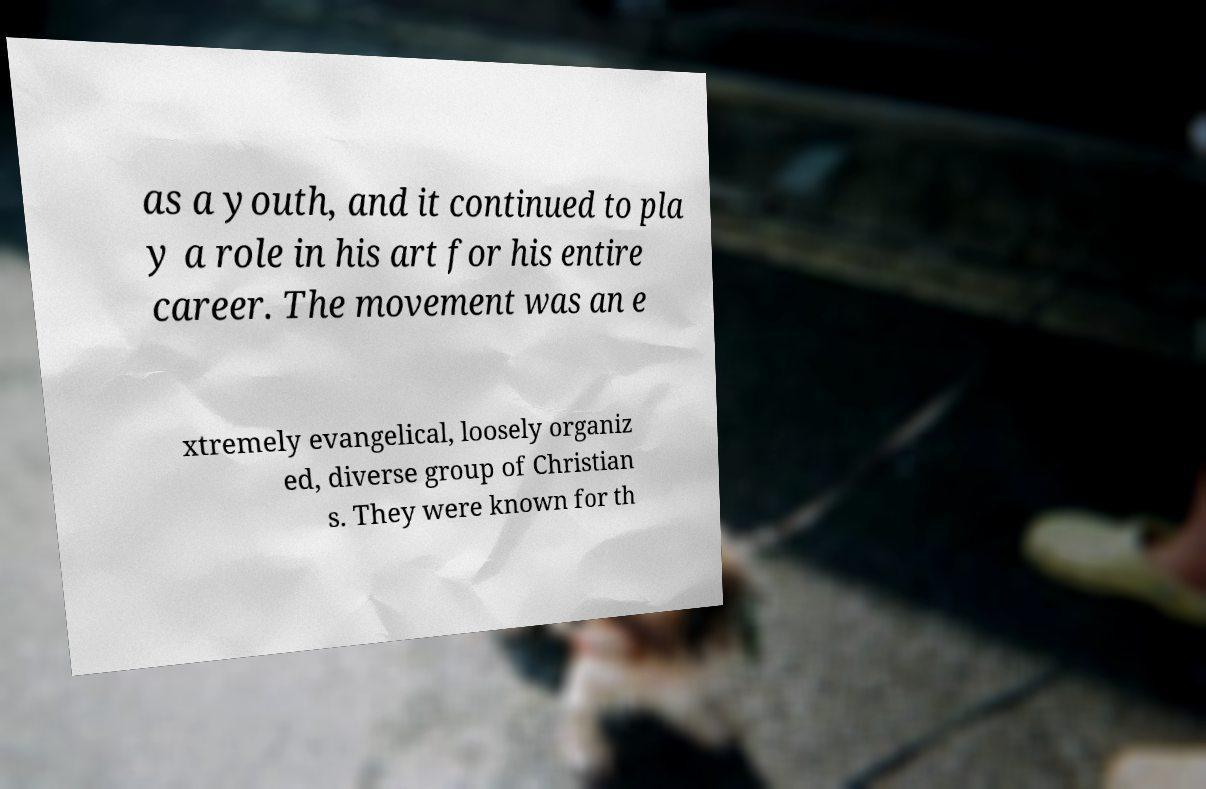Could you assist in decoding the text presented in this image and type it out clearly? as a youth, and it continued to pla y a role in his art for his entire career. The movement was an e xtremely evangelical, loosely organiz ed, diverse group of Christian s. They were known for th 